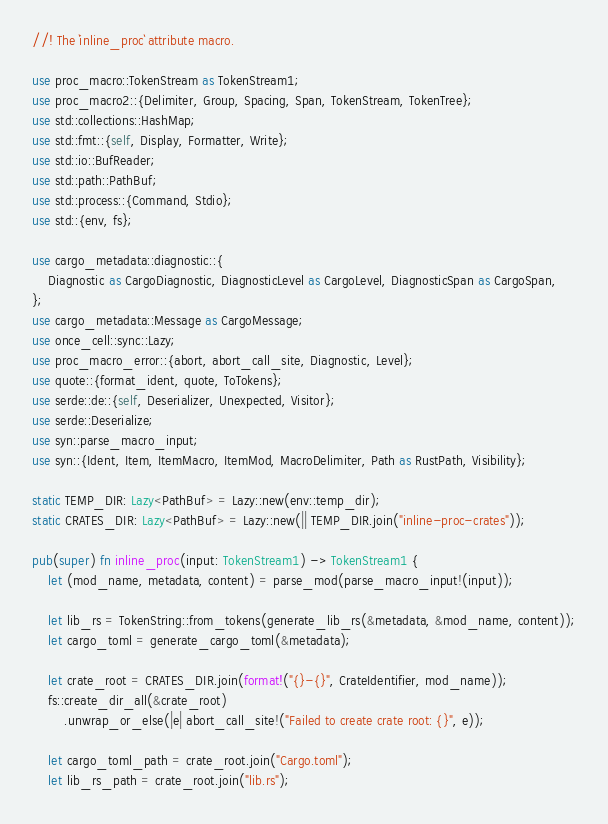Convert code to text. <code><loc_0><loc_0><loc_500><loc_500><_Rust_>//! The `inline_proc` attribute macro.

use proc_macro::TokenStream as TokenStream1;
use proc_macro2::{Delimiter, Group, Spacing, Span, TokenStream, TokenTree};
use std::collections::HashMap;
use std::fmt::{self, Display, Formatter, Write};
use std::io::BufReader;
use std::path::PathBuf;
use std::process::{Command, Stdio};
use std::{env, fs};

use cargo_metadata::diagnostic::{
    Diagnostic as CargoDiagnostic, DiagnosticLevel as CargoLevel, DiagnosticSpan as CargoSpan,
};
use cargo_metadata::Message as CargoMessage;
use once_cell::sync::Lazy;
use proc_macro_error::{abort, abort_call_site, Diagnostic, Level};
use quote::{format_ident, quote, ToTokens};
use serde::de::{self, Deserializer, Unexpected, Visitor};
use serde::Deserialize;
use syn::parse_macro_input;
use syn::{Ident, Item, ItemMacro, ItemMod, MacroDelimiter, Path as RustPath, Visibility};

static TEMP_DIR: Lazy<PathBuf> = Lazy::new(env::temp_dir);
static CRATES_DIR: Lazy<PathBuf> = Lazy::new(|| TEMP_DIR.join("inline-proc-crates"));

pub(super) fn inline_proc(input: TokenStream1) -> TokenStream1 {
    let (mod_name, metadata, content) = parse_mod(parse_macro_input!(input));

    let lib_rs = TokenString::from_tokens(generate_lib_rs(&metadata, &mod_name, content));
    let cargo_toml = generate_cargo_toml(&metadata);

    let crate_root = CRATES_DIR.join(format!("{}-{}", CrateIdentifier, mod_name));
    fs::create_dir_all(&crate_root)
        .unwrap_or_else(|e| abort_call_site!("Failed to create crate root: {}", e));

    let cargo_toml_path = crate_root.join("Cargo.toml");
    let lib_rs_path = crate_root.join("lib.rs");
</code> 